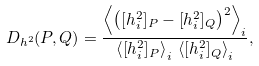Convert formula to latex. <formula><loc_0><loc_0><loc_500><loc_500>D _ { h ^ { 2 } } ( P , Q ) = \frac { \left < \left ( [ h ^ { 2 } _ { i } ] _ { P } - [ h ^ { 2 } _ { i } ] _ { Q } \right ) ^ { 2 } \right > _ { i } } { \left < [ h ^ { 2 } _ { i } ] _ { P } \right > _ { i } \, \left < [ h ^ { 2 } _ { i } ] _ { Q } \right > _ { i } } ,</formula> 